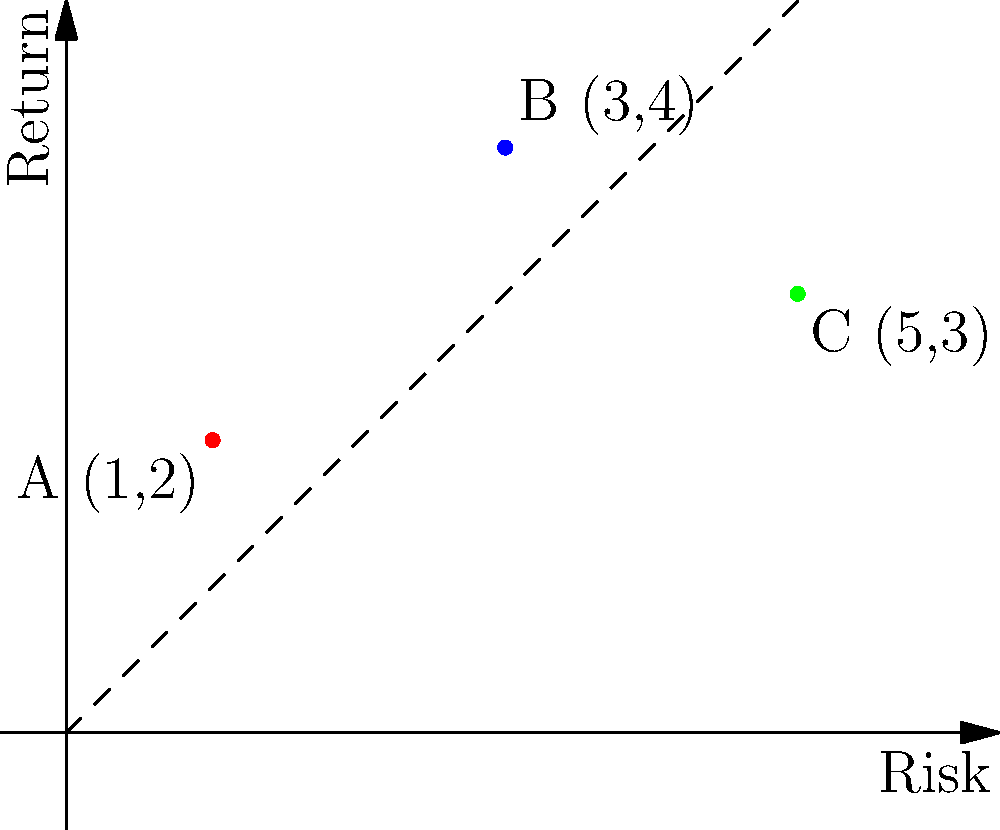In the graph above, points A, B, and C represent different investment portfolios plotted on a risk-return plane. Portfolio A has coordinates (1,2), B has (3,4), and C has (5,3). If you want to create a new portfolio D that is a weighted combination of portfolios A and B, with 60% weight on A and 40% on B, what are the coordinates of portfolio D? Express your answer as an ordered pair $(x,y)$. To find the coordinates of portfolio D, we need to calculate the weighted average of the coordinates of portfolios A and B. Let's approach this step-by-step:

1) Portfolio A coordinates: $(1,2)$
   Portfolio B coordinates: $(3,4)$

2) Weight for A: 60% = 0.6
   Weight for B: 40% = 0.4

3) Calculate the x-coordinate of D:
   $x_D = 0.6 \cdot x_A + 0.4 \cdot x_B$
   $x_D = 0.6 \cdot 1 + 0.4 \cdot 3 = 0.6 + 1.2 = 1.8$

4) Calculate the y-coordinate of D:
   $y_D = 0.6 \cdot y_A + 0.4 \cdot y_B$
   $y_D = 0.6 \cdot 2 + 0.4 \cdot 4 = 1.2 + 1.6 = 2.8$

5) Therefore, the coordinates of portfolio D are $(1.8, 2.8)$.

This method of creating new portfolios through weighted combinations is a fundamental concept in modern portfolio theory, which is likely of interest to someone working at Finance House and admiring financial experts like Mohammed Alqubaisi.
Answer: $(1.8, 2.8)$ 